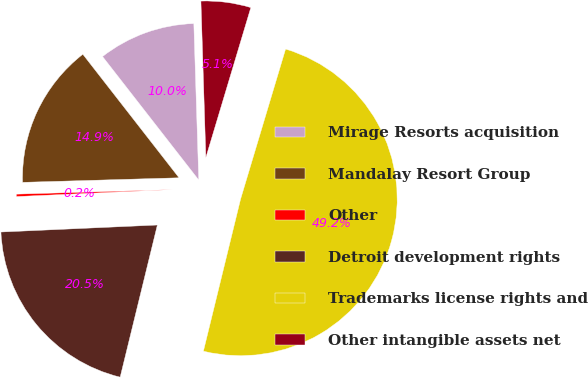<chart> <loc_0><loc_0><loc_500><loc_500><pie_chart><fcel>Mirage Resorts acquisition<fcel>Mandalay Resort Group<fcel>Other<fcel>Detroit development rights<fcel>Trademarks license rights and<fcel>Other intangible assets net<nl><fcel>10.03%<fcel>14.93%<fcel>0.25%<fcel>20.47%<fcel>49.18%<fcel>5.14%<nl></chart> 